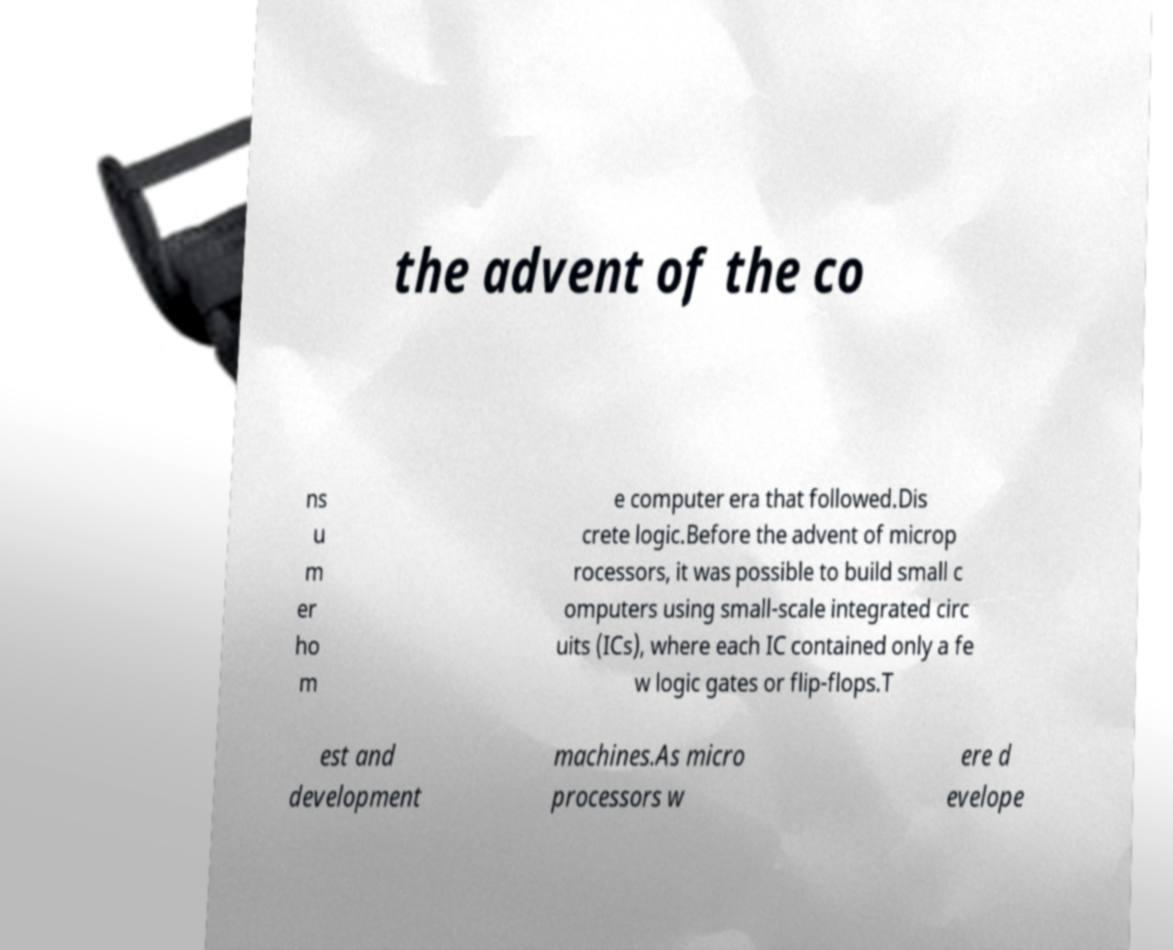Please read and relay the text visible in this image. What does it say? the advent of the co ns u m er ho m e computer era that followed.Dis crete logic.Before the advent of microp rocessors, it was possible to build small c omputers using small-scale integrated circ uits (ICs), where each IC contained only a fe w logic gates or flip-flops.T est and development machines.As micro processors w ere d evelope 